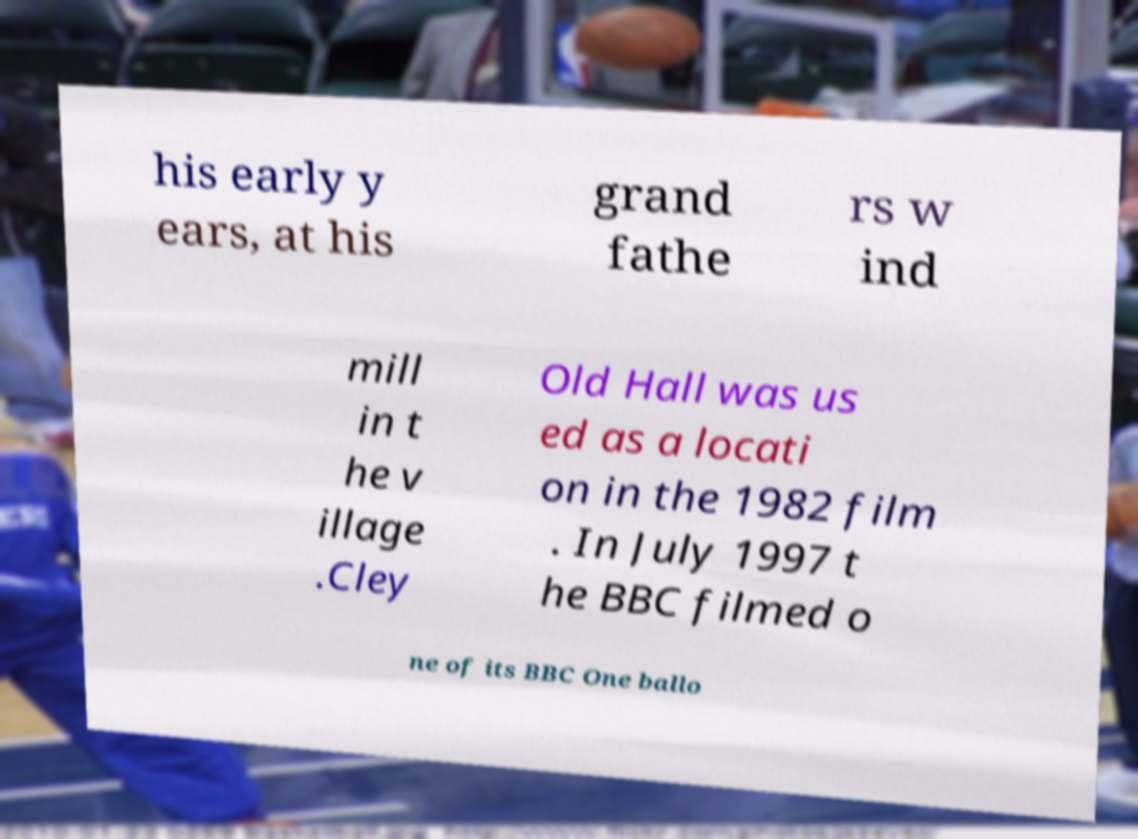I need the written content from this picture converted into text. Can you do that? his early y ears, at his grand fathe rs w ind mill in t he v illage .Cley Old Hall was us ed as a locati on in the 1982 film . In July 1997 t he BBC filmed o ne of its BBC One ballo 